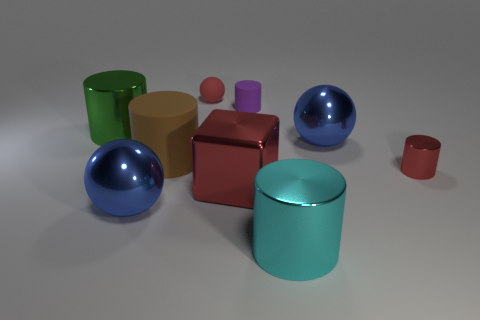Subtract all large cyan metal cylinders. How many cylinders are left? 4 Subtract all red cylinders. How many cylinders are left? 4 Subtract all blue cylinders. Subtract all yellow balls. How many cylinders are left? 5 Add 1 cyan things. How many objects exist? 10 Subtract all spheres. How many objects are left? 6 Add 7 gray rubber spheres. How many gray rubber spheres exist? 7 Subtract 0 gray blocks. How many objects are left? 9 Subtract all purple cylinders. Subtract all big cyan metal cylinders. How many objects are left? 7 Add 5 spheres. How many spheres are left? 8 